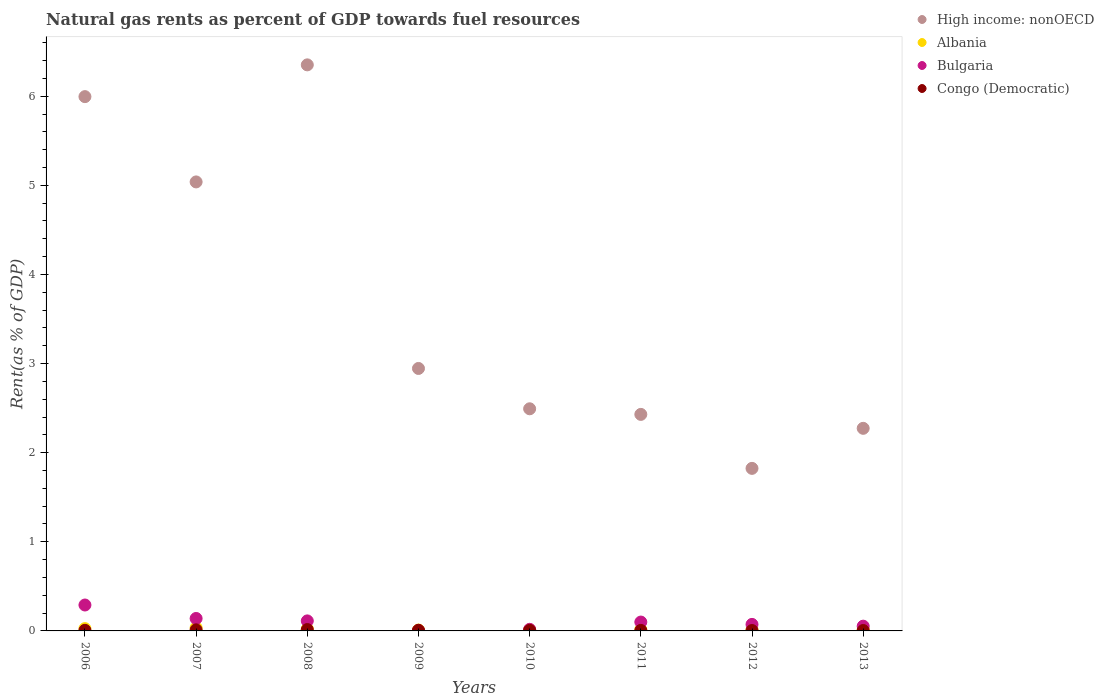Is the number of dotlines equal to the number of legend labels?
Provide a succinct answer. Yes. What is the matural gas rent in Congo (Democratic) in 2011?
Your answer should be compact. 0.01. Across all years, what is the maximum matural gas rent in Bulgaria?
Your answer should be compact. 0.29. Across all years, what is the minimum matural gas rent in Albania?
Make the answer very short. 0.01. What is the total matural gas rent in High income: nonOECD in the graph?
Give a very brief answer. 29.35. What is the difference between the matural gas rent in Congo (Democratic) in 2006 and that in 2012?
Provide a succinct answer. 0. What is the difference between the matural gas rent in Congo (Democratic) in 2011 and the matural gas rent in Albania in 2012?
Your answer should be very brief. -0.01. What is the average matural gas rent in Congo (Democratic) per year?
Give a very brief answer. 0.01. In the year 2008, what is the difference between the matural gas rent in Congo (Democratic) and matural gas rent in Albania?
Provide a short and direct response. -0.01. What is the ratio of the matural gas rent in Congo (Democratic) in 2007 to that in 2013?
Your response must be concise. 2.74. What is the difference between the highest and the second highest matural gas rent in Albania?
Your answer should be very brief. 0.01. What is the difference between the highest and the lowest matural gas rent in High income: nonOECD?
Your answer should be compact. 4.53. In how many years, is the matural gas rent in High income: nonOECD greater than the average matural gas rent in High income: nonOECD taken over all years?
Provide a short and direct response. 3. Does the matural gas rent in Albania monotonically increase over the years?
Provide a short and direct response. No. Is the matural gas rent in Bulgaria strictly greater than the matural gas rent in Congo (Democratic) over the years?
Your response must be concise. No. Is the matural gas rent in Congo (Democratic) strictly less than the matural gas rent in High income: nonOECD over the years?
Your answer should be very brief. Yes. How many dotlines are there?
Your response must be concise. 4. How many years are there in the graph?
Keep it short and to the point. 8. Does the graph contain any zero values?
Make the answer very short. No. How many legend labels are there?
Your answer should be very brief. 4. How are the legend labels stacked?
Keep it short and to the point. Vertical. What is the title of the graph?
Your response must be concise. Natural gas rents as percent of GDP towards fuel resources. Does "Syrian Arab Republic" appear as one of the legend labels in the graph?
Your answer should be very brief. No. What is the label or title of the X-axis?
Provide a succinct answer. Years. What is the label or title of the Y-axis?
Your answer should be very brief. Rent(as % of GDP). What is the Rent(as % of GDP) of High income: nonOECD in 2006?
Ensure brevity in your answer.  6. What is the Rent(as % of GDP) of Albania in 2006?
Make the answer very short. 0.03. What is the Rent(as % of GDP) of Bulgaria in 2006?
Your answer should be compact. 0.29. What is the Rent(as % of GDP) in Congo (Democratic) in 2006?
Your answer should be compact. 0.01. What is the Rent(as % of GDP) in High income: nonOECD in 2007?
Provide a short and direct response. 5.04. What is the Rent(as % of GDP) of Albania in 2007?
Keep it short and to the point. 0.03. What is the Rent(as % of GDP) in Bulgaria in 2007?
Make the answer very short. 0.14. What is the Rent(as % of GDP) in Congo (Democratic) in 2007?
Offer a very short reply. 0.01. What is the Rent(as % of GDP) in High income: nonOECD in 2008?
Provide a short and direct response. 6.35. What is the Rent(as % of GDP) of Albania in 2008?
Provide a succinct answer. 0.02. What is the Rent(as % of GDP) in Bulgaria in 2008?
Make the answer very short. 0.11. What is the Rent(as % of GDP) in Congo (Democratic) in 2008?
Make the answer very short. 0.02. What is the Rent(as % of GDP) of High income: nonOECD in 2009?
Ensure brevity in your answer.  2.95. What is the Rent(as % of GDP) in Albania in 2009?
Offer a terse response. 0.01. What is the Rent(as % of GDP) in Bulgaria in 2009?
Your answer should be compact. 0. What is the Rent(as % of GDP) of Congo (Democratic) in 2009?
Provide a succinct answer. 0.01. What is the Rent(as % of GDP) in High income: nonOECD in 2010?
Provide a succinct answer. 2.49. What is the Rent(as % of GDP) of Albania in 2010?
Make the answer very short. 0.01. What is the Rent(as % of GDP) in Bulgaria in 2010?
Your answer should be compact. 0.02. What is the Rent(as % of GDP) in Congo (Democratic) in 2010?
Offer a terse response. 0.01. What is the Rent(as % of GDP) of High income: nonOECD in 2011?
Your answer should be compact. 2.43. What is the Rent(as % of GDP) of Albania in 2011?
Provide a short and direct response. 0.01. What is the Rent(as % of GDP) of Bulgaria in 2011?
Your answer should be very brief. 0.1. What is the Rent(as % of GDP) of Congo (Democratic) in 2011?
Offer a very short reply. 0.01. What is the Rent(as % of GDP) of High income: nonOECD in 2012?
Offer a very short reply. 1.82. What is the Rent(as % of GDP) of Albania in 2012?
Offer a terse response. 0.01. What is the Rent(as % of GDP) of Bulgaria in 2012?
Keep it short and to the point. 0.07. What is the Rent(as % of GDP) in Congo (Democratic) in 2012?
Give a very brief answer. 0. What is the Rent(as % of GDP) in High income: nonOECD in 2013?
Your response must be concise. 2.27. What is the Rent(as % of GDP) in Albania in 2013?
Make the answer very short. 0.02. What is the Rent(as % of GDP) of Bulgaria in 2013?
Ensure brevity in your answer.  0.05. What is the Rent(as % of GDP) of Congo (Democratic) in 2013?
Your response must be concise. 0. Across all years, what is the maximum Rent(as % of GDP) of High income: nonOECD?
Ensure brevity in your answer.  6.35. Across all years, what is the maximum Rent(as % of GDP) of Albania?
Offer a terse response. 0.03. Across all years, what is the maximum Rent(as % of GDP) in Bulgaria?
Ensure brevity in your answer.  0.29. Across all years, what is the maximum Rent(as % of GDP) of Congo (Democratic)?
Provide a succinct answer. 0.02. Across all years, what is the minimum Rent(as % of GDP) in High income: nonOECD?
Ensure brevity in your answer.  1.82. Across all years, what is the minimum Rent(as % of GDP) of Albania?
Give a very brief answer. 0.01. Across all years, what is the minimum Rent(as % of GDP) in Bulgaria?
Offer a terse response. 0. Across all years, what is the minimum Rent(as % of GDP) in Congo (Democratic)?
Your answer should be very brief. 0. What is the total Rent(as % of GDP) of High income: nonOECD in the graph?
Your answer should be very brief. 29.35. What is the total Rent(as % of GDP) of Albania in the graph?
Your answer should be very brief. 0.15. What is the total Rent(as % of GDP) of Bulgaria in the graph?
Your response must be concise. 0.79. What is the total Rent(as % of GDP) in Congo (Democratic) in the graph?
Your answer should be compact. 0.06. What is the difference between the Rent(as % of GDP) of Albania in 2006 and that in 2007?
Keep it short and to the point. -0.01. What is the difference between the Rent(as % of GDP) in Bulgaria in 2006 and that in 2007?
Give a very brief answer. 0.15. What is the difference between the Rent(as % of GDP) in Congo (Democratic) in 2006 and that in 2007?
Your answer should be very brief. -0.01. What is the difference between the Rent(as % of GDP) in High income: nonOECD in 2006 and that in 2008?
Offer a very short reply. -0.36. What is the difference between the Rent(as % of GDP) of Albania in 2006 and that in 2008?
Your response must be concise. 0. What is the difference between the Rent(as % of GDP) in Bulgaria in 2006 and that in 2008?
Make the answer very short. 0.18. What is the difference between the Rent(as % of GDP) in Congo (Democratic) in 2006 and that in 2008?
Offer a very short reply. -0.01. What is the difference between the Rent(as % of GDP) of High income: nonOECD in 2006 and that in 2009?
Offer a very short reply. 3.05. What is the difference between the Rent(as % of GDP) of Albania in 2006 and that in 2009?
Your response must be concise. 0.02. What is the difference between the Rent(as % of GDP) of Bulgaria in 2006 and that in 2009?
Provide a succinct answer. 0.29. What is the difference between the Rent(as % of GDP) in Congo (Democratic) in 2006 and that in 2009?
Your answer should be very brief. -0. What is the difference between the Rent(as % of GDP) in High income: nonOECD in 2006 and that in 2010?
Ensure brevity in your answer.  3.5. What is the difference between the Rent(as % of GDP) of Albania in 2006 and that in 2010?
Your response must be concise. 0.01. What is the difference between the Rent(as % of GDP) in Bulgaria in 2006 and that in 2010?
Ensure brevity in your answer.  0.27. What is the difference between the Rent(as % of GDP) in Congo (Democratic) in 2006 and that in 2010?
Your response must be concise. 0. What is the difference between the Rent(as % of GDP) of High income: nonOECD in 2006 and that in 2011?
Provide a short and direct response. 3.57. What is the difference between the Rent(as % of GDP) in Albania in 2006 and that in 2011?
Ensure brevity in your answer.  0.01. What is the difference between the Rent(as % of GDP) in Bulgaria in 2006 and that in 2011?
Give a very brief answer. 0.19. What is the difference between the Rent(as % of GDP) in Congo (Democratic) in 2006 and that in 2011?
Give a very brief answer. 0. What is the difference between the Rent(as % of GDP) in High income: nonOECD in 2006 and that in 2012?
Give a very brief answer. 4.17. What is the difference between the Rent(as % of GDP) of Albania in 2006 and that in 2012?
Give a very brief answer. 0.01. What is the difference between the Rent(as % of GDP) of Bulgaria in 2006 and that in 2012?
Make the answer very short. 0.22. What is the difference between the Rent(as % of GDP) in Congo (Democratic) in 2006 and that in 2012?
Ensure brevity in your answer.  0. What is the difference between the Rent(as % of GDP) in High income: nonOECD in 2006 and that in 2013?
Offer a very short reply. 3.72. What is the difference between the Rent(as % of GDP) in Albania in 2006 and that in 2013?
Make the answer very short. 0.01. What is the difference between the Rent(as % of GDP) of Bulgaria in 2006 and that in 2013?
Your response must be concise. 0.24. What is the difference between the Rent(as % of GDP) of Congo (Democratic) in 2006 and that in 2013?
Give a very brief answer. 0. What is the difference between the Rent(as % of GDP) in High income: nonOECD in 2007 and that in 2008?
Provide a short and direct response. -1.31. What is the difference between the Rent(as % of GDP) in Albania in 2007 and that in 2008?
Provide a short and direct response. 0.01. What is the difference between the Rent(as % of GDP) of Bulgaria in 2007 and that in 2008?
Your response must be concise. 0.03. What is the difference between the Rent(as % of GDP) of Congo (Democratic) in 2007 and that in 2008?
Provide a succinct answer. -0. What is the difference between the Rent(as % of GDP) of High income: nonOECD in 2007 and that in 2009?
Offer a terse response. 2.09. What is the difference between the Rent(as % of GDP) in Albania in 2007 and that in 2009?
Your answer should be compact. 0.03. What is the difference between the Rent(as % of GDP) in Bulgaria in 2007 and that in 2009?
Your response must be concise. 0.14. What is the difference between the Rent(as % of GDP) in Congo (Democratic) in 2007 and that in 2009?
Keep it short and to the point. 0. What is the difference between the Rent(as % of GDP) in High income: nonOECD in 2007 and that in 2010?
Your response must be concise. 2.55. What is the difference between the Rent(as % of GDP) of Albania in 2007 and that in 2010?
Your response must be concise. 0.02. What is the difference between the Rent(as % of GDP) of Bulgaria in 2007 and that in 2010?
Make the answer very short. 0.12. What is the difference between the Rent(as % of GDP) of Congo (Democratic) in 2007 and that in 2010?
Keep it short and to the point. 0.01. What is the difference between the Rent(as % of GDP) of High income: nonOECD in 2007 and that in 2011?
Your answer should be compact. 2.61. What is the difference between the Rent(as % of GDP) in Albania in 2007 and that in 2011?
Offer a terse response. 0.02. What is the difference between the Rent(as % of GDP) of Bulgaria in 2007 and that in 2011?
Ensure brevity in your answer.  0.04. What is the difference between the Rent(as % of GDP) of Congo (Democratic) in 2007 and that in 2011?
Provide a succinct answer. 0.01. What is the difference between the Rent(as % of GDP) of High income: nonOECD in 2007 and that in 2012?
Provide a succinct answer. 3.21. What is the difference between the Rent(as % of GDP) of Albania in 2007 and that in 2012?
Keep it short and to the point. 0.02. What is the difference between the Rent(as % of GDP) in Bulgaria in 2007 and that in 2012?
Your answer should be compact. 0.07. What is the difference between the Rent(as % of GDP) in Congo (Democratic) in 2007 and that in 2012?
Your answer should be compact. 0.01. What is the difference between the Rent(as % of GDP) of High income: nonOECD in 2007 and that in 2013?
Your answer should be compact. 2.77. What is the difference between the Rent(as % of GDP) of Albania in 2007 and that in 2013?
Keep it short and to the point. 0.02. What is the difference between the Rent(as % of GDP) in Bulgaria in 2007 and that in 2013?
Offer a very short reply. 0.09. What is the difference between the Rent(as % of GDP) in Congo (Democratic) in 2007 and that in 2013?
Offer a terse response. 0.01. What is the difference between the Rent(as % of GDP) of High income: nonOECD in 2008 and that in 2009?
Offer a very short reply. 3.41. What is the difference between the Rent(as % of GDP) of Albania in 2008 and that in 2009?
Offer a very short reply. 0.01. What is the difference between the Rent(as % of GDP) of Bulgaria in 2008 and that in 2009?
Offer a terse response. 0.11. What is the difference between the Rent(as % of GDP) of Congo (Democratic) in 2008 and that in 2009?
Provide a succinct answer. 0.01. What is the difference between the Rent(as % of GDP) in High income: nonOECD in 2008 and that in 2010?
Your answer should be compact. 3.86. What is the difference between the Rent(as % of GDP) in Albania in 2008 and that in 2010?
Your answer should be compact. 0.01. What is the difference between the Rent(as % of GDP) in Bulgaria in 2008 and that in 2010?
Your answer should be compact. 0.09. What is the difference between the Rent(as % of GDP) in Congo (Democratic) in 2008 and that in 2010?
Ensure brevity in your answer.  0.01. What is the difference between the Rent(as % of GDP) in High income: nonOECD in 2008 and that in 2011?
Make the answer very short. 3.92. What is the difference between the Rent(as % of GDP) in Albania in 2008 and that in 2011?
Keep it short and to the point. 0.01. What is the difference between the Rent(as % of GDP) of Bulgaria in 2008 and that in 2011?
Provide a short and direct response. 0.01. What is the difference between the Rent(as % of GDP) of Congo (Democratic) in 2008 and that in 2011?
Your answer should be very brief. 0.01. What is the difference between the Rent(as % of GDP) of High income: nonOECD in 2008 and that in 2012?
Give a very brief answer. 4.53. What is the difference between the Rent(as % of GDP) of Albania in 2008 and that in 2012?
Give a very brief answer. 0.01. What is the difference between the Rent(as % of GDP) in Bulgaria in 2008 and that in 2012?
Offer a very short reply. 0.04. What is the difference between the Rent(as % of GDP) in Congo (Democratic) in 2008 and that in 2012?
Offer a very short reply. 0.01. What is the difference between the Rent(as % of GDP) of High income: nonOECD in 2008 and that in 2013?
Keep it short and to the point. 4.08. What is the difference between the Rent(as % of GDP) in Albania in 2008 and that in 2013?
Your answer should be compact. 0.01. What is the difference between the Rent(as % of GDP) in Bulgaria in 2008 and that in 2013?
Ensure brevity in your answer.  0.06. What is the difference between the Rent(as % of GDP) in Congo (Democratic) in 2008 and that in 2013?
Offer a terse response. 0.01. What is the difference between the Rent(as % of GDP) in High income: nonOECD in 2009 and that in 2010?
Provide a succinct answer. 0.45. What is the difference between the Rent(as % of GDP) of Albania in 2009 and that in 2010?
Keep it short and to the point. -0. What is the difference between the Rent(as % of GDP) in Bulgaria in 2009 and that in 2010?
Offer a terse response. -0.01. What is the difference between the Rent(as % of GDP) of Congo (Democratic) in 2009 and that in 2010?
Your answer should be very brief. 0. What is the difference between the Rent(as % of GDP) of High income: nonOECD in 2009 and that in 2011?
Your answer should be very brief. 0.52. What is the difference between the Rent(as % of GDP) in Albania in 2009 and that in 2011?
Keep it short and to the point. -0. What is the difference between the Rent(as % of GDP) in Bulgaria in 2009 and that in 2011?
Offer a very short reply. -0.1. What is the difference between the Rent(as % of GDP) of Congo (Democratic) in 2009 and that in 2011?
Keep it short and to the point. 0. What is the difference between the Rent(as % of GDP) in High income: nonOECD in 2009 and that in 2012?
Provide a succinct answer. 1.12. What is the difference between the Rent(as % of GDP) in Albania in 2009 and that in 2012?
Your answer should be compact. -0. What is the difference between the Rent(as % of GDP) in Bulgaria in 2009 and that in 2012?
Your answer should be compact. -0.07. What is the difference between the Rent(as % of GDP) of Congo (Democratic) in 2009 and that in 2012?
Offer a very short reply. 0. What is the difference between the Rent(as % of GDP) of High income: nonOECD in 2009 and that in 2013?
Keep it short and to the point. 0.67. What is the difference between the Rent(as % of GDP) of Albania in 2009 and that in 2013?
Offer a terse response. -0.01. What is the difference between the Rent(as % of GDP) of Bulgaria in 2009 and that in 2013?
Provide a succinct answer. -0.05. What is the difference between the Rent(as % of GDP) of Congo (Democratic) in 2009 and that in 2013?
Provide a short and direct response. 0. What is the difference between the Rent(as % of GDP) in High income: nonOECD in 2010 and that in 2011?
Keep it short and to the point. 0.06. What is the difference between the Rent(as % of GDP) of Albania in 2010 and that in 2011?
Your answer should be compact. -0. What is the difference between the Rent(as % of GDP) in Bulgaria in 2010 and that in 2011?
Make the answer very short. -0.08. What is the difference between the Rent(as % of GDP) in High income: nonOECD in 2010 and that in 2012?
Keep it short and to the point. 0.67. What is the difference between the Rent(as % of GDP) in Albania in 2010 and that in 2012?
Provide a succinct answer. 0. What is the difference between the Rent(as % of GDP) of Bulgaria in 2010 and that in 2012?
Offer a very short reply. -0.06. What is the difference between the Rent(as % of GDP) in Congo (Democratic) in 2010 and that in 2012?
Your answer should be very brief. 0. What is the difference between the Rent(as % of GDP) of High income: nonOECD in 2010 and that in 2013?
Offer a terse response. 0.22. What is the difference between the Rent(as % of GDP) of Albania in 2010 and that in 2013?
Give a very brief answer. -0. What is the difference between the Rent(as % of GDP) in Bulgaria in 2010 and that in 2013?
Your answer should be compact. -0.04. What is the difference between the Rent(as % of GDP) in Congo (Democratic) in 2010 and that in 2013?
Provide a short and direct response. 0. What is the difference between the Rent(as % of GDP) in High income: nonOECD in 2011 and that in 2012?
Your answer should be compact. 0.61. What is the difference between the Rent(as % of GDP) in Albania in 2011 and that in 2012?
Make the answer very short. 0. What is the difference between the Rent(as % of GDP) in Bulgaria in 2011 and that in 2012?
Make the answer very short. 0.03. What is the difference between the Rent(as % of GDP) of Congo (Democratic) in 2011 and that in 2012?
Offer a very short reply. 0. What is the difference between the Rent(as % of GDP) in High income: nonOECD in 2011 and that in 2013?
Make the answer very short. 0.16. What is the difference between the Rent(as % of GDP) of Albania in 2011 and that in 2013?
Make the answer very short. -0. What is the difference between the Rent(as % of GDP) in Bulgaria in 2011 and that in 2013?
Your answer should be compact. 0.05. What is the difference between the Rent(as % of GDP) in Congo (Democratic) in 2011 and that in 2013?
Provide a short and direct response. 0. What is the difference between the Rent(as % of GDP) of High income: nonOECD in 2012 and that in 2013?
Your answer should be compact. -0.45. What is the difference between the Rent(as % of GDP) in Albania in 2012 and that in 2013?
Offer a terse response. -0. What is the difference between the Rent(as % of GDP) of Bulgaria in 2012 and that in 2013?
Provide a short and direct response. 0.02. What is the difference between the Rent(as % of GDP) of Congo (Democratic) in 2012 and that in 2013?
Keep it short and to the point. -0. What is the difference between the Rent(as % of GDP) of High income: nonOECD in 2006 and the Rent(as % of GDP) of Albania in 2007?
Keep it short and to the point. 5.96. What is the difference between the Rent(as % of GDP) of High income: nonOECD in 2006 and the Rent(as % of GDP) of Bulgaria in 2007?
Your answer should be very brief. 5.86. What is the difference between the Rent(as % of GDP) in High income: nonOECD in 2006 and the Rent(as % of GDP) in Congo (Democratic) in 2007?
Offer a very short reply. 5.98. What is the difference between the Rent(as % of GDP) of Albania in 2006 and the Rent(as % of GDP) of Bulgaria in 2007?
Your answer should be compact. -0.11. What is the difference between the Rent(as % of GDP) in Albania in 2006 and the Rent(as % of GDP) in Congo (Democratic) in 2007?
Offer a terse response. 0.01. What is the difference between the Rent(as % of GDP) in Bulgaria in 2006 and the Rent(as % of GDP) in Congo (Democratic) in 2007?
Provide a short and direct response. 0.28. What is the difference between the Rent(as % of GDP) of High income: nonOECD in 2006 and the Rent(as % of GDP) of Albania in 2008?
Ensure brevity in your answer.  5.97. What is the difference between the Rent(as % of GDP) in High income: nonOECD in 2006 and the Rent(as % of GDP) in Bulgaria in 2008?
Your answer should be compact. 5.88. What is the difference between the Rent(as % of GDP) in High income: nonOECD in 2006 and the Rent(as % of GDP) in Congo (Democratic) in 2008?
Your answer should be compact. 5.98. What is the difference between the Rent(as % of GDP) of Albania in 2006 and the Rent(as % of GDP) of Bulgaria in 2008?
Provide a succinct answer. -0.09. What is the difference between the Rent(as % of GDP) in Albania in 2006 and the Rent(as % of GDP) in Congo (Democratic) in 2008?
Your answer should be compact. 0.01. What is the difference between the Rent(as % of GDP) of Bulgaria in 2006 and the Rent(as % of GDP) of Congo (Democratic) in 2008?
Give a very brief answer. 0.28. What is the difference between the Rent(as % of GDP) of High income: nonOECD in 2006 and the Rent(as % of GDP) of Albania in 2009?
Your answer should be compact. 5.99. What is the difference between the Rent(as % of GDP) in High income: nonOECD in 2006 and the Rent(as % of GDP) in Bulgaria in 2009?
Provide a short and direct response. 5.99. What is the difference between the Rent(as % of GDP) in High income: nonOECD in 2006 and the Rent(as % of GDP) in Congo (Democratic) in 2009?
Your response must be concise. 5.99. What is the difference between the Rent(as % of GDP) of Albania in 2006 and the Rent(as % of GDP) of Bulgaria in 2009?
Your response must be concise. 0.02. What is the difference between the Rent(as % of GDP) in Albania in 2006 and the Rent(as % of GDP) in Congo (Democratic) in 2009?
Your response must be concise. 0.02. What is the difference between the Rent(as % of GDP) of Bulgaria in 2006 and the Rent(as % of GDP) of Congo (Democratic) in 2009?
Provide a short and direct response. 0.28. What is the difference between the Rent(as % of GDP) of High income: nonOECD in 2006 and the Rent(as % of GDP) of Albania in 2010?
Ensure brevity in your answer.  5.98. What is the difference between the Rent(as % of GDP) of High income: nonOECD in 2006 and the Rent(as % of GDP) of Bulgaria in 2010?
Provide a short and direct response. 5.98. What is the difference between the Rent(as % of GDP) in High income: nonOECD in 2006 and the Rent(as % of GDP) in Congo (Democratic) in 2010?
Your response must be concise. 5.99. What is the difference between the Rent(as % of GDP) of Albania in 2006 and the Rent(as % of GDP) of Bulgaria in 2010?
Give a very brief answer. 0.01. What is the difference between the Rent(as % of GDP) of Albania in 2006 and the Rent(as % of GDP) of Congo (Democratic) in 2010?
Your response must be concise. 0.02. What is the difference between the Rent(as % of GDP) in Bulgaria in 2006 and the Rent(as % of GDP) in Congo (Democratic) in 2010?
Your answer should be compact. 0.28. What is the difference between the Rent(as % of GDP) in High income: nonOECD in 2006 and the Rent(as % of GDP) in Albania in 2011?
Provide a succinct answer. 5.98. What is the difference between the Rent(as % of GDP) of High income: nonOECD in 2006 and the Rent(as % of GDP) of Bulgaria in 2011?
Your answer should be compact. 5.9. What is the difference between the Rent(as % of GDP) of High income: nonOECD in 2006 and the Rent(as % of GDP) of Congo (Democratic) in 2011?
Your answer should be very brief. 5.99. What is the difference between the Rent(as % of GDP) in Albania in 2006 and the Rent(as % of GDP) in Bulgaria in 2011?
Ensure brevity in your answer.  -0.07. What is the difference between the Rent(as % of GDP) in Albania in 2006 and the Rent(as % of GDP) in Congo (Democratic) in 2011?
Ensure brevity in your answer.  0.02. What is the difference between the Rent(as % of GDP) of Bulgaria in 2006 and the Rent(as % of GDP) of Congo (Democratic) in 2011?
Give a very brief answer. 0.28. What is the difference between the Rent(as % of GDP) of High income: nonOECD in 2006 and the Rent(as % of GDP) of Albania in 2012?
Your response must be concise. 5.98. What is the difference between the Rent(as % of GDP) of High income: nonOECD in 2006 and the Rent(as % of GDP) of Bulgaria in 2012?
Make the answer very short. 5.92. What is the difference between the Rent(as % of GDP) in High income: nonOECD in 2006 and the Rent(as % of GDP) in Congo (Democratic) in 2012?
Your answer should be compact. 5.99. What is the difference between the Rent(as % of GDP) in Albania in 2006 and the Rent(as % of GDP) in Bulgaria in 2012?
Keep it short and to the point. -0.05. What is the difference between the Rent(as % of GDP) in Albania in 2006 and the Rent(as % of GDP) in Congo (Democratic) in 2012?
Provide a succinct answer. 0.02. What is the difference between the Rent(as % of GDP) of Bulgaria in 2006 and the Rent(as % of GDP) of Congo (Democratic) in 2012?
Keep it short and to the point. 0.29. What is the difference between the Rent(as % of GDP) in High income: nonOECD in 2006 and the Rent(as % of GDP) in Albania in 2013?
Your response must be concise. 5.98. What is the difference between the Rent(as % of GDP) in High income: nonOECD in 2006 and the Rent(as % of GDP) in Bulgaria in 2013?
Offer a very short reply. 5.94. What is the difference between the Rent(as % of GDP) of High income: nonOECD in 2006 and the Rent(as % of GDP) of Congo (Democratic) in 2013?
Your response must be concise. 5.99. What is the difference between the Rent(as % of GDP) in Albania in 2006 and the Rent(as % of GDP) in Bulgaria in 2013?
Keep it short and to the point. -0.03. What is the difference between the Rent(as % of GDP) in Albania in 2006 and the Rent(as % of GDP) in Congo (Democratic) in 2013?
Your response must be concise. 0.02. What is the difference between the Rent(as % of GDP) of Bulgaria in 2006 and the Rent(as % of GDP) of Congo (Democratic) in 2013?
Keep it short and to the point. 0.29. What is the difference between the Rent(as % of GDP) of High income: nonOECD in 2007 and the Rent(as % of GDP) of Albania in 2008?
Your response must be concise. 5.02. What is the difference between the Rent(as % of GDP) of High income: nonOECD in 2007 and the Rent(as % of GDP) of Bulgaria in 2008?
Offer a very short reply. 4.93. What is the difference between the Rent(as % of GDP) of High income: nonOECD in 2007 and the Rent(as % of GDP) of Congo (Democratic) in 2008?
Your answer should be compact. 5.02. What is the difference between the Rent(as % of GDP) of Albania in 2007 and the Rent(as % of GDP) of Bulgaria in 2008?
Offer a terse response. -0.08. What is the difference between the Rent(as % of GDP) of Albania in 2007 and the Rent(as % of GDP) of Congo (Democratic) in 2008?
Your answer should be compact. 0.02. What is the difference between the Rent(as % of GDP) in Bulgaria in 2007 and the Rent(as % of GDP) in Congo (Democratic) in 2008?
Provide a short and direct response. 0.12. What is the difference between the Rent(as % of GDP) of High income: nonOECD in 2007 and the Rent(as % of GDP) of Albania in 2009?
Provide a short and direct response. 5.03. What is the difference between the Rent(as % of GDP) in High income: nonOECD in 2007 and the Rent(as % of GDP) in Bulgaria in 2009?
Make the answer very short. 5.03. What is the difference between the Rent(as % of GDP) in High income: nonOECD in 2007 and the Rent(as % of GDP) in Congo (Democratic) in 2009?
Provide a succinct answer. 5.03. What is the difference between the Rent(as % of GDP) of Albania in 2007 and the Rent(as % of GDP) of Bulgaria in 2009?
Keep it short and to the point. 0.03. What is the difference between the Rent(as % of GDP) in Albania in 2007 and the Rent(as % of GDP) in Congo (Democratic) in 2009?
Ensure brevity in your answer.  0.03. What is the difference between the Rent(as % of GDP) of Bulgaria in 2007 and the Rent(as % of GDP) of Congo (Democratic) in 2009?
Ensure brevity in your answer.  0.13. What is the difference between the Rent(as % of GDP) of High income: nonOECD in 2007 and the Rent(as % of GDP) of Albania in 2010?
Offer a very short reply. 5.02. What is the difference between the Rent(as % of GDP) in High income: nonOECD in 2007 and the Rent(as % of GDP) in Bulgaria in 2010?
Your answer should be compact. 5.02. What is the difference between the Rent(as % of GDP) in High income: nonOECD in 2007 and the Rent(as % of GDP) in Congo (Democratic) in 2010?
Ensure brevity in your answer.  5.03. What is the difference between the Rent(as % of GDP) in Albania in 2007 and the Rent(as % of GDP) in Bulgaria in 2010?
Ensure brevity in your answer.  0.02. What is the difference between the Rent(as % of GDP) of Albania in 2007 and the Rent(as % of GDP) of Congo (Democratic) in 2010?
Give a very brief answer. 0.03. What is the difference between the Rent(as % of GDP) of Bulgaria in 2007 and the Rent(as % of GDP) of Congo (Democratic) in 2010?
Ensure brevity in your answer.  0.13. What is the difference between the Rent(as % of GDP) in High income: nonOECD in 2007 and the Rent(as % of GDP) in Albania in 2011?
Ensure brevity in your answer.  5.02. What is the difference between the Rent(as % of GDP) in High income: nonOECD in 2007 and the Rent(as % of GDP) in Bulgaria in 2011?
Give a very brief answer. 4.94. What is the difference between the Rent(as % of GDP) in High income: nonOECD in 2007 and the Rent(as % of GDP) in Congo (Democratic) in 2011?
Give a very brief answer. 5.03. What is the difference between the Rent(as % of GDP) in Albania in 2007 and the Rent(as % of GDP) in Bulgaria in 2011?
Provide a succinct answer. -0.06. What is the difference between the Rent(as % of GDP) of Albania in 2007 and the Rent(as % of GDP) of Congo (Democratic) in 2011?
Offer a very short reply. 0.03. What is the difference between the Rent(as % of GDP) in Bulgaria in 2007 and the Rent(as % of GDP) in Congo (Democratic) in 2011?
Give a very brief answer. 0.13. What is the difference between the Rent(as % of GDP) of High income: nonOECD in 2007 and the Rent(as % of GDP) of Albania in 2012?
Give a very brief answer. 5.03. What is the difference between the Rent(as % of GDP) in High income: nonOECD in 2007 and the Rent(as % of GDP) in Bulgaria in 2012?
Your answer should be very brief. 4.97. What is the difference between the Rent(as % of GDP) in High income: nonOECD in 2007 and the Rent(as % of GDP) in Congo (Democratic) in 2012?
Make the answer very short. 5.03. What is the difference between the Rent(as % of GDP) in Albania in 2007 and the Rent(as % of GDP) in Bulgaria in 2012?
Offer a very short reply. -0.04. What is the difference between the Rent(as % of GDP) in Albania in 2007 and the Rent(as % of GDP) in Congo (Democratic) in 2012?
Offer a very short reply. 0.03. What is the difference between the Rent(as % of GDP) of Bulgaria in 2007 and the Rent(as % of GDP) of Congo (Democratic) in 2012?
Provide a short and direct response. 0.14. What is the difference between the Rent(as % of GDP) in High income: nonOECD in 2007 and the Rent(as % of GDP) in Albania in 2013?
Your response must be concise. 5.02. What is the difference between the Rent(as % of GDP) of High income: nonOECD in 2007 and the Rent(as % of GDP) of Bulgaria in 2013?
Provide a succinct answer. 4.99. What is the difference between the Rent(as % of GDP) of High income: nonOECD in 2007 and the Rent(as % of GDP) of Congo (Democratic) in 2013?
Your answer should be compact. 5.03. What is the difference between the Rent(as % of GDP) of Albania in 2007 and the Rent(as % of GDP) of Bulgaria in 2013?
Give a very brief answer. -0.02. What is the difference between the Rent(as % of GDP) in Albania in 2007 and the Rent(as % of GDP) in Congo (Democratic) in 2013?
Provide a short and direct response. 0.03. What is the difference between the Rent(as % of GDP) of Bulgaria in 2007 and the Rent(as % of GDP) of Congo (Democratic) in 2013?
Give a very brief answer. 0.14. What is the difference between the Rent(as % of GDP) in High income: nonOECD in 2008 and the Rent(as % of GDP) in Albania in 2009?
Provide a short and direct response. 6.34. What is the difference between the Rent(as % of GDP) in High income: nonOECD in 2008 and the Rent(as % of GDP) in Bulgaria in 2009?
Offer a very short reply. 6.35. What is the difference between the Rent(as % of GDP) of High income: nonOECD in 2008 and the Rent(as % of GDP) of Congo (Democratic) in 2009?
Your answer should be compact. 6.34. What is the difference between the Rent(as % of GDP) of Albania in 2008 and the Rent(as % of GDP) of Bulgaria in 2009?
Your response must be concise. 0.02. What is the difference between the Rent(as % of GDP) in Albania in 2008 and the Rent(as % of GDP) in Congo (Democratic) in 2009?
Your answer should be compact. 0.01. What is the difference between the Rent(as % of GDP) in Bulgaria in 2008 and the Rent(as % of GDP) in Congo (Democratic) in 2009?
Your answer should be compact. 0.11. What is the difference between the Rent(as % of GDP) of High income: nonOECD in 2008 and the Rent(as % of GDP) of Albania in 2010?
Offer a terse response. 6.34. What is the difference between the Rent(as % of GDP) in High income: nonOECD in 2008 and the Rent(as % of GDP) in Bulgaria in 2010?
Give a very brief answer. 6.33. What is the difference between the Rent(as % of GDP) in High income: nonOECD in 2008 and the Rent(as % of GDP) in Congo (Democratic) in 2010?
Keep it short and to the point. 6.35. What is the difference between the Rent(as % of GDP) of Albania in 2008 and the Rent(as % of GDP) of Bulgaria in 2010?
Give a very brief answer. 0. What is the difference between the Rent(as % of GDP) of Albania in 2008 and the Rent(as % of GDP) of Congo (Democratic) in 2010?
Offer a terse response. 0.02. What is the difference between the Rent(as % of GDP) of Bulgaria in 2008 and the Rent(as % of GDP) of Congo (Democratic) in 2010?
Keep it short and to the point. 0.11. What is the difference between the Rent(as % of GDP) of High income: nonOECD in 2008 and the Rent(as % of GDP) of Albania in 2011?
Your answer should be compact. 6.34. What is the difference between the Rent(as % of GDP) in High income: nonOECD in 2008 and the Rent(as % of GDP) in Bulgaria in 2011?
Offer a terse response. 6.25. What is the difference between the Rent(as % of GDP) of High income: nonOECD in 2008 and the Rent(as % of GDP) of Congo (Democratic) in 2011?
Give a very brief answer. 6.35. What is the difference between the Rent(as % of GDP) of Albania in 2008 and the Rent(as % of GDP) of Bulgaria in 2011?
Ensure brevity in your answer.  -0.08. What is the difference between the Rent(as % of GDP) in Albania in 2008 and the Rent(as % of GDP) in Congo (Democratic) in 2011?
Give a very brief answer. 0.02. What is the difference between the Rent(as % of GDP) of Bulgaria in 2008 and the Rent(as % of GDP) of Congo (Democratic) in 2011?
Give a very brief answer. 0.11. What is the difference between the Rent(as % of GDP) of High income: nonOECD in 2008 and the Rent(as % of GDP) of Albania in 2012?
Offer a terse response. 6.34. What is the difference between the Rent(as % of GDP) of High income: nonOECD in 2008 and the Rent(as % of GDP) of Bulgaria in 2012?
Your answer should be compact. 6.28. What is the difference between the Rent(as % of GDP) of High income: nonOECD in 2008 and the Rent(as % of GDP) of Congo (Democratic) in 2012?
Offer a terse response. 6.35. What is the difference between the Rent(as % of GDP) of Albania in 2008 and the Rent(as % of GDP) of Bulgaria in 2012?
Ensure brevity in your answer.  -0.05. What is the difference between the Rent(as % of GDP) of Albania in 2008 and the Rent(as % of GDP) of Congo (Democratic) in 2012?
Offer a terse response. 0.02. What is the difference between the Rent(as % of GDP) of Bulgaria in 2008 and the Rent(as % of GDP) of Congo (Democratic) in 2012?
Your answer should be compact. 0.11. What is the difference between the Rent(as % of GDP) in High income: nonOECD in 2008 and the Rent(as % of GDP) in Albania in 2013?
Offer a terse response. 6.34. What is the difference between the Rent(as % of GDP) of High income: nonOECD in 2008 and the Rent(as % of GDP) of Bulgaria in 2013?
Give a very brief answer. 6.3. What is the difference between the Rent(as % of GDP) in High income: nonOECD in 2008 and the Rent(as % of GDP) in Congo (Democratic) in 2013?
Your response must be concise. 6.35. What is the difference between the Rent(as % of GDP) in Albania in 2008 and the Rent(as % of GDP) in Bulgaria in 2013?
Offer a terse response. -0.03. What is the difference between the Rent(as % of GDP) in Albania in 2008 and the Rent(as % of GDP) in Congo (Democratic) in 2013?
Ensure brevity in your answer.  0.02. What is the difference between the Rent(as % of GDP) in Bulgaria in 2008 and the Rent(as % of GDP) in Congo (Democratic) in 2013?
Provide a short and direct response. 0.11. What is the difference between the Rent(as % of GDP) of High income: nonOECD in 2009 and the Rent(as % of GDP) of Albania in 2010?
Provide a short and direct response. 2.93. What is the difference between the Rent(as % of GDP) in High income: nonOECD in 2009 and the Rent(as % of GDP) in Bulgaria in 2010?
Give a very brief answer. 2.93. What is the difference between the Rent(as % of GDP) in High income: nonOECD in 2009 and the Rent(as % of GDP) in Congo (Democratic) in 2010?
Provide a short and direct response. 2.94. What is the difference between the Rent(as % of GDP) of Albania in 2009 and the Rent(as % of GDP) of Bulgaria in 2010?
Provide a short and direct response. -0.01. What is the difference between the Rent(as % of GDP) in Albania in 2009 and the Rent(as % of GDP) in Congo (Democratic) in 2010?
Make the answer very short. 0. What is the difference between the Rent(as % of GDP) in Bulgaria in 2009 and the Rent(as % of GDP) in Congo (Democratic) in 2010?
Your response must be concise. -0. What is the difference between the Rent(as % of GDP) of High income: nonOECD in 2009 and the Rent(as % of GDP) of Albania in 2011?
Offer a terse response. 2.93. What is the difference between the Rent(as % of GDP) in High income: nonOECD in 2009 and the Rent(as % of GDP) in Bulgaria in 2011?
Your answer should be compact. 2.85. What is the difference between the Rent(as % of GDP) of High income: nonOECD in 2009 and the Rent(as % of GDP) of Congo (Democratic) in 2011?
Make the answer very short. 2.94. What is the difference between the Rent(as % of GDP) of Albania in 2009 and the Rent(as % of GDP) of Bulgaria in 2011?
Provide a short and direct response. -0.09. What is the difference between the Rent(as % of GDP) in Albania in 2009 and the Rent(as % of GDP) in Congo (Democratic) in 2011?
Provide a short and direct response. 0. What is the difference between the Rent(as % of GDP) of Bulgaria in 2009 and the Rent(as % of GDP) of Congo (Democratic) in 2011?
Your answer should be very brief. -0. What is the difference between the Rent(as % of GDP) in High income: nonOECD in 2009 and the Rent(as % of GDP) in Albania in 2012?
Your answer should be very brief. 2.93. What is the difference between the Rent(as % of GDP) of High income: nonOECD in 2009 and the Rent(as % of GDP) of Bulgaria in 2012?
Offer a very short reply. 2.87. What is the difference between the Rent(as % of GDP) in High income: nonOECD in 2009 and the Rent(as % of GDP) in Congo (Democratic) in 2012?
Your answer should be compact. 2.94. What is the difference between the Rent(as % of GDP) of Albania in 2009 and the Rent(as % of GDP) of Bulgaria in 2012?
Keep it short and to the point. -0.06. What is the difference between the Rent(as % of GDP) in Albania in 2009 and the Rent(as % of GDP) in Congo (Democratic) in 2012?
Provide a succinct answer. 0.01. What is the difference between the Rent(as % of GDP) in Bulgaria in 2009 and the Rent(as % of GDP) in Congo (Democratic) in 2012?
Provide a short and direct response. -0. What is the difference between the Rent(as % of GDP) in High income: nonOECD in 2009 and the Rent(as % of GDP) in Albania in 2013?
Your answer should be very brief. 2.93. What is the difference between the Rent(as % of GDP) in High income: nonOECD in 2009 and the Rent(as % of GDP) in Bulgaria in 2013?
Ensure brevity in your answer.  2.89. What is the difference between the Rent(as % of GDP) of High income: nonOECD in 2009 and the Rent(as % of GDP) of Congo (Democratic) in 2013?
Your response must be concise. 2.94. What is the difference between the Rent(as % of GDP) of Albania in 2009 and the Rent(as % of GDP) of Bulgaria in 2013?
Your response must be concise. -0.04. What is the difference between the Rent(as % of GDP) of Albania in 2009 and the Rent(as % of GDP) of Congo (Democratic) in 2013?
Provide a short and direct response. 0.01. What is the difference between the Rent(as % of GDP) in Bulgaria in 2009 and the Rent(as % of GDP) in Congo (Democratic) in 2013?
Your answer should be very brief. -0. What is the difference between the Rent(as % of GDP) of High income: nonOECD in 2010 and the Rent(as % of GDP) of Albania in 2011?
Keep it short and to the point. 2.48. What is the difference between the Rent(as % of GDP) of High income: nonOECD in 2010 and the Rent(as % of GDP) of Bulgaria in 2011?
Your response must be concise. 2.39. What is the difference between the Rent(as % of GDP) in High income: nonOECD in 2010 and the Rent(as % of GDP) in Congo (Democratic) in 2011?
Keep it short and to the point. 2.49. What is the difference between the Rent(as % of GDP) of Albania in 2010 and the Rent(as % of GDP) of Bulgaria in 2011?
Provide a succinct answer. -0.09. What is the difference between the Rent(as % of GDP) in Albania in 2010 and the Rent(as % of GDP) in Congo (Democratic) in 2011?
Your answer should be compact. 0.01. What is the difference between the Rent(as % of GDP) of Bulgaria in 2010 and the Rent(as % of GDP) of Congo (Democratic) in 2011?
Offer a terse response. 0.01. What is the difference between the Rent(as % of GDP) of High income: nonOECD in 2010 and the Rent(as % of GDP) of Albania in 2012?
Make the answer very short. 2.48. What is the difference between the Rent(as % of GDP) in High income: nonOECD in 2010 and the Rent(as % of GDP) in Bulgaria in 2012?
Make the answer very short. 2.42. What is the difference between the Rent(as % of GDP) in High income: nonOECD in 2010 and the Rent(as % of GDP) in Congo (Democratic) in 2012?
Make the answer very short. 2.49. What is the difference between the Rent(as % of GDP) of Albania in 2010 and the Rent(as % of GDP) of Bulgaria in 2012?
Provide a succinct answer. -0.06. What is the difference between the Rent(as % of GDP) in Albania in 2010 and the Rent(as % of GDP) in Congo (Democratic) in 2012?
Give a very brief answer. 0.01. What is the difference between the Rent(as % of GDP) of Bulgaria in 2010 and the Rent(as % of GDP) of Congo (Democratic) in 2012?
Keep it short and to the point. 0.01. What is the difference between the Rent(as % of GDP) of High income: nonOECD in 2010 and the Rent(as % of GDP) of Albania in 2013?
Offer a very short reply. 2.48. What is the difference between the Rent(as % of GDP) in High income: nonOECD in 2010 and the Rent(as % of GDP) in Bulgaria in 2013?
Ensure brevity in your answer.  2.44. What is the difference between the Rent(as % of GDP) in High income: nonOECD in 2010 and the Rent(as % of GDP) in Congo (Democratic) in 2013?
Provide a succinct answer. 2.49. What is the difference between the Rent(as % of GDP) in Albania in 2010 and the Rent(as % of GDP) in Bulgaria in 2013?
Your response must be concise. -0.04. What is the difference between the Rent(as % of GDP) of Albania in 2010 and the Rent(as % of GDP) of Congo (Democratic) in 2013?
Your answer should be compact. 0.01. What is the difference between the Rent(as % of GDP) in Bulgaria in 2010 and the Rent(as % of GDP) in Congo (Democratic) in 2013?
Give a very brief answer. 0.01. What is the difference between the Rent(as % of GDP) in High income: nonOECD in 2011 and the Rent(as % of GDP) in Albania in 2012?
Your answer should be compact. 2.42. What is the difference between the Rent(as % of GDP) of High income: nonOECD in 2011 and the Rent(as % of GDP) of Bulgaria in 2012?
Provide a succinct answer. 2.36. What is the difference between the Rent(as % of GDP) of High income: nonOECD in 2011 and the Rent(as % of GDP) of Congo (Democratic) in 2012?
Offer a terse response. 2.43. What is the difference between the Rent(as % of GDP) in Albania in 2011 and the Rent(as % of GDP) in Bulgaria in 2012?
Provide a succinct answer. -0.06. What is the difference between the Rent(as % of GDP) in Albania in 2011 and the Rent(as % of GDP) in Congo (Democratic) in 2012?
Provide a short and direct response. 0.01. What is the difference between the Rent(as % of GDP) in Bulgaria in 2011 and the Rent(as % of GDP) in Congo (Democratic) in 2012?
Give a very brief answer. 0.1. What is the difference between the Rent(as % of GDP) of High income: nonOECD in 2011 and the Rent(as % of GDP) of Albania in 2013?
Provide a short and direct response. 2.41. What is the difference between the Rent(as % of GDP) in High income: nonOECD in 2011 and the Rent(as % of GDP) in Bulgaria in 2013?
Your answer should be very brief. 2.38. What is the difference between the Rent(as % of GDP) of High income: nonOECD in 2011 and the Rent(as % of GDP) of Congo (Democratic) in 2013?
Your response must be concise. 2.43. What is the difference between the Rent(as % of GDP) in Albania in 2011 and the Rent(as % of GDP) in Bulgaria in 2013?
Give a very brief answer. -0.04. What is the difference between the Rent(as % of GDP) of Albania in 2011 and the Rent(as % of GDP) of Congo (Democratic) in 2013?
Provide a short and direct response. 0.01. What is the difference between the Rent(as % of GDP) in Bulgaria in 2011 and the Rent(as % of GDP) in Congo (Democratic) in 2013?
Offer a terse response. 0.1. What is the difference between the Rent(as % of GDP) of High income: nonOECD in 2012 and the Rent(as % of GDP) of Albania in 2013?
Your answer should be compact. 1.81. What is the difference between the Rent(as % of GDP) of High income: nonOECD in 2012 and the Rent(as % of GDP) of Bulgaria in 2013?
Your answer should be compact. 1.77. What is the difference between the Rent(as % of GDP) of High income: nonOECD in 2012 and the Rent(as % of GDP) of Congo (Democratic) in 2013?
Your answer should be compact. 1.82. What is the difference between the Rent(as % of GDP) of Albania in 2012 and the Rent(as % of GDP) of Bulgaria in 2013?
Ensure brevity in your answer.  -0.04. What is the difference between the Rent(as % of GDP) of Albania in 2012 and the Rent(as % of GDP) of Congo (Democratic) in 2013?
Provide a succinct answer. 0.01. What is the difference between the Rent(as % of GDP) of Bulgaria in 2012 and the Rent(as % of GDP) of Congo (Democratic) in 2013?
Make the answer very short. 0.07. What is the average Rent(as % of GDP) of High income: nonOECD per year?
Offer a very short reply. 3.67. What is the average Rent(as % of GDP) of Albania per year?
Your response must be concise. 0.02. What is the average Rent(as % of GDP) in Bulgaria per year?
Your answer should be compact. 0.1. What is the average Rent(as % of GDP) of Congo (Democratic) per year?
Provide a succinct answer. 0.01. In the year 2006, what is the difference between the Rent(as % of GDP) in High income: nonOECD and Rent(as % of GDP) in Albania?
Your answer should be very brief. 5.97. In the year 2006, what is the difference between the Rent(as % of GDP) in High income: nonOECD and Rent(as % of GDP) in Bulgaria?
Offer a terse response. 5.7. In the year 2006, what is the difference between the Rent(as % of GDP) of High income: nonOECD and Rent(as % of GDP) of Congo (Democratic)?
Make the answer very short. 5.99. In the year 2006, what is the difference between the Rent(as % of GDP) of Albania and Rent(as % of GDP) of Bulgaria?
Your response must be concise. -0.27. In the year 2006, what is the difference between the Rent(as % of GDP) in Albania and Rent(as % of GDP) in Congo (Democratic)?
Your answer should be very brief. 0.02. In the year 2006, what is the difference between the Rent(as % of GDP) in Bulgaria and Rent(as % of GDP) in Congo (Democratic)?
Your answer should be very brief. 0.28. In the year 2007, what is the difference between the Rent(as % of GDP) in High income: nonOECD and Rent(as % of GDP) in Albania?
Your response must be concise. 5. In the year 2007, what is the difference between the Rent(as % of GDP) in High income: nonOECD and Rent(as % of GDP) in Bulgaria?
Keep it short and to the point. 4.9. In the year 2007, what is the difference between the Rent(as % of GDP) of High income: nonOECD and Rent(as % of GDP) of Congo (Democratic)?
Make the answer very short. 5.03. In the year 2007, what is the difference between the Rent(as % of GDP) of Albania and Rent(as % of GDP) of Bulgaria?
Offer a terse response. -0.1. In the year 2007, what is the difference between the Rent(as % of GDP) in Albania and Rent(as % of GDP) in Congo (Democratic)?
Your response must be concise. 0.02. In the year 2007, what is the difference between the Rent(as % of GDP) of Bulgaria and Rent(as % of GDP) of Congo (Democratic)?
Offer a very short reply. 0.13. In the year 2008, what is the difference between the Rent(as % of GDP) in High income: nonOECD and Rent(as % of GDP) in Albania?
Make the answer very short. 6.33. In the year 2008, what is the difference between the Rent(as % of GDP) in High income: nonOECD and Rent(as % of GDP) in Bulgaria?
Provide a succinct answer. 6.24. In the year 2008, what is the difference between the Rent(as % of GDP) in High income: nonOECD and Rent(as % of GDP) in Congo (Democratic)?
Offer a very short reply. 6.34. In the year 2008, what is the difference between the Rent(as % of GDP) of Albania and Rent(as % of GDP) of Bulgaria?
Your response must be concise. -0.09. In the year 2008, what is the difference between the Rent(as % of GDP) in Albania and Rent(as % of GDP) in Congo (Democratic)?
Provide a short and direct response. 0.01. In the year 2008, what is the difference between the Rent(as % of GDP) in Bulgaria and Rent(as % of GDP) in Congo (Democratic)?
Offer a very short reply. 0.1. In the year 2009, what is the difference between the Rent(as % of GDP) in High income: nonOECD and Rent(as % of GDP) in Albania?
Offer a terse response. 2.94. In the year 2009, what is the difference between the Rent(as % of GDP) of High income: nonOECD and Rent(as % of GDP) of Bulgaria?
Offer a very short reply. 2.94. In the year 2009, what is the difference between the Rent(as % of GDP) of High income: nonOECD and Rent(as % of GDP) of Congo (Democratic)?
Ensure brevity in your answer.  2.94. In the year 2009, what is the difference between the Rent(as % of GDP) in Albania and Rent(as % of GDP) in Bulgaria?
Keep it short and to the point. 0.01. In the year 2009, what is the difference between the Rent(as % of GDP) in Albania and Rent(as % of GDP) in Congo (Democratic)?
Offer a terse response. 0. In the year 2009, what is the difference between the Rent(as % of GDP) of Bulgaria and Rent(as % of GDP) of Congo (Democratic)?
Keep it short and to the point. -0. In the year 2010, what is the difference between the Rent(as % of GDP) of High income: nonOECD and Rent(as % of GDP) of Albania?
Keep it short and to the point. 2.48. In the year 2010, what is the difference between the Rent(as % of GDP) of High income: nonOECD and Rent(as % of GDP) of Bulgaria?
Offer a very short reply. 2.48. In the year 2010, what is the difference between the Rent(as % of GDP) in High income: nonOECD and Rent(as % of GDP) in Congo (Democratic)?
Provide a succinct answer. 2.49. In the year 2010, what is the difference between the Rent(as % of GDP) of Albania and Rent(as % of GDP) of Bulgaria?
Your answer should be very brief. -0. In the year 2010, what is the difference between the Rent(as % of GDP) of Albania and Rent(as % of GDP) of Congo (Democratic)?
Offer a very short reply. 0.01. In the year 2010, what is the difference between the Rent(as % of GDP) in Bulgaria and Rent(as % of GDP) in Congo (Democratic)?
Give a very brief answer. 0.01. In the year 2011, what is the difference between the Rent(as % of GDP) in High income: nonOECD and Rent(as % of GDP) in Albania?
Your answer should be very brief. 2.42. In the year 2011, what is the difference between the Rent(as % of GDP) in High income: nonOECD and Rent(as % of GDP) in Bulgaria?
Ensure brevity in your answer.  2.33. In the year 2011, what is the difference between the Rent(as % of GDP) of High income: nonOECD and Rent(as % of GDP) of Congo (Democratic)?
Offer a very short reply. 2.42. In the year 2011, what is the difference between the Rent(as % of GDP) of Albania and Rent(as % of GDP) of Bulgaria?
Ensure brevity in your answer.  -0.08. In the year 2011, what is the difference between the Rent(as % of GDP) in Albania and Rent(as % of GDP) in Congo (Democratic)?
Keep it short and to the point. 0.01. In the year 2011, what is the difference between the Rent(as % of GDP) of Bulgaria and Rent(as % of GDP) of Congo (Democratic)?
Your response must be concise. 0.09. In the year 2012, what is the difference between the Rent(as % of GDP) of High income: nonOECD and Rent(as % of GDP) of Albania?
Make the answer very short. 1.81. In the year 2012, what is the difference between the Rent(as % of GDP) in High income: nonOECD and Rent(as % of GDP) in Bulgaria?
Your answer should be compact. 1.75. In the year 2012, what is the difference between the Rent(as % of GDP) in High income: nonOECD and Rent(as % of GDP) in Congo (Democratic)?
Your answer should be compact. 1.82. In the year 2012, what is the difference between the Rent(as % of GDP) in Albania and Rent(as % of GDP) in Bulgaria?
Offer a terse response. -0.06. In the year 2012, what is the difference between the Rent(as % of GDP) of Albania and Rent(as % of GDP) of Congo (Democratic)?
Offer a very short reply. 0.01. In the year 2012, what is the difference between the Rent(as % of GDP) in Bulgaria and Rent(as % of GDP) in Congo (Democratic)?
Your answer should be very brief. 0.07. In the year 2013, what is the difference between the Rent(as % of GDP) in High income: nonOECD and Rent(as % of GDP) in Albania?
Offer a terse response. 2.26. In the year 2013, what is the difference between the Rent(as % of GDP) in High income: nonOECD and Rent(as % of GDP) in Bulgaria?
Your response must be concise. 2.22. In the year 2013, what is the difference between the Rent(as % of GDP) in High income: nonOECD and Rent(as % of GDP) in Congo (Democratic)?
Your response must be concise. 2.27. In the year 2013, what is the difference between the Rent(as % of GDP) of Albania and Rent(as % of GDP) of Bulgaria?
Your answer should be compact. -0.04. In the year 2013, what is the difference between the Rent(as % of GDP) in Albania and Rent(as % of GDP) in Congo (Democratic)?
Provide a short and direct response. 0.01. In the year 2013, what is the difference between the Rent(as % of GDP) in Bulgaria and Rent(as % of GDP) in Congo (Democratic)?
Your answer should be compact. 0.05. What is the ratio of the Rent(as % of GDP) in High income: nonOECD in 2006 to that in 2007?
Make the answer very short. 1.19. What is the ratio of the Rent(as % of GDP) of Albania in 2006 to that in 2007?
Offer a terse response. 0.74. What is the ratio of the Rent(as % of GDP) of Bulgaria in 2006 to that in 2007?
Ensure brevity in your answer.  2.08. What is the ratio of the Rent(as % of GDP) of Congo (Democratic) in 2006 to that in 2007?
Your answer should be compact. 0.55. What is the ratio of the Rent(as % of GDP) of High income: nonOECD in 2006 to that in 2008?
Offer a terse response. 0.94. What is the ratio of the Rent(as % of GDP) of Albania in 2006 to that in 2008?
Offer a very short reply. 1.2. What is the ratio of the Rent(as % of GDP) of Bulgaria in 2006 to that in 2008?
Provide a short and direct response. 2.58. What is the ratio of the Rent(as % of GDP) of Congo (Democratic) in 2006 to that in 2008?
Give a very brief answer. 0.44. What is the ratio of the Rent(as % of GDP) of High income: nonOECD in 2006 to that in 2009?
Your answer should be compact. 2.04. What is the ratio of the Rent(as % of GDP) in Albania in 2006 to that in 2009?
Your answer should be compact. 2.63. What is the ratio of the Rent(as % of GDP) of Bulgaria in 2006 to that in 2009?
Make the answer very short. 69.34. What is the ratio of the Rent(as % of GDP) in Congo (Democratic) in 2006 to that in 2009?
Offer a very short reply. 0.91. What is the ratio of the Rent(as % of GDP) in High income: nonOECD in 2006 to that in 2010?
Your answer should be compact. 2.41. What is the ratio of the Rent(as % of GDP) of Albania in 2006 to that in 2010?
Make the answer very short. 1.83. What is the ratio of the Rent(as % of GDP) in Bulgaria in 2006 to that in 2010?
Provide a short and direct response. 16.42. What is the ratio of the Rent(as % of GDP) of Congo (Democratic) in 2006 to that in 2010?
Ensure brevity in your answer.  1.09. What is the ratio of the Rent(as % of GDP) in High income: nonOECD in 2006 to that in 2011?
Your answer should be compact. 2.47. What is the ratio of the Rent(as % of GDP) in Albania in 2006 to that in 2011?
Offer a very short reply. 1.75. What is the ratio of the Rent(as % of GDP) in Bulgaria in 2006 to that in 2011?
Make the answer very short. 2.92. What is the ratio of the Rent(as % of GDP) in Congo (Democratic) in 2006 to that in 2011?
Offer a very short reply. 1.14. What is the ratio of the Rent(as % of GDP) in High income: nonOECD in 2006 to that in 2012?
Offer a terse response. 3.29. What is the ratio of the Rent(as % of GDP) of Albania in 2006 to that in 2012?
Offer a very short reply. 1.93. What is the ratio of the Rent(as % of GDP) in Bulgaria in 2006 to that in 2012?
Offer a terse response. 3.97. What is the ratio of the Rent(as % of GDP) in Congo (Democratic) in 2006 to that in 2012?
Provide a short and direct response. 1.53. What is the ratio of the Rent(as % of GDP) in High income: nonOECD in 2006 to that in 2013?
Your answer should be very brief. 2.64. What is the ratio of the Rent(as % of GDP) in Albania in 2006 to that in 2013?
Keep it short and to the point. 1.72. What is the ratio of the Rent(as % of GDP) of Bulgaria in 2006 to that in 2013?
Provide a succinct answer. 5.45. What is the ratio of the Rent(as % of GDP) of Congo (Democratic) in 2006 to that in 2013?
Keep it short and to the point. 1.52. What is the ratio of the Rent(as % of GDP) of High income: nonOECD in 2007 to that in 2008?
Your answer should be compact. 0.79. What is the ratio of the Rent(as % of GDP) of Albania in 2007 to that in 2008?
Give a very brief answer. 1.62. What is the ratio of the Rent(as % of GDP) in Bulgaria in 2007 to that in 2008?
Offer a terse response. 1.24. What is the ratio of the Rent(as % of GDP) in Congo (Democratic) in 2007 to that in 2008?
Provide a short and direct response. 0.8. What is the ratio of the Rent(as % of GDP) of High income: nonOECD in 2007 to that in 2009?
Your answer should be compact. 1.71. What is the ratio of the Rent(as % of GDP) of Albania in 2007 to that in 2009?
Offer a very short reply. 3.55. What is the ratio of the Rent(as % of GDP) in Bulgaria in 2007 to that in 2009?
Give a very brief answer. 33.32. What is the ratio of the Rent(as % of GDP) of Congo (Democratic) in 2007 to that in 2009?
Provide a succinct answer. 1.65. What is the ratio of the Rent(as % of GDP) in High income: nonOECD in 2007 to that in 2010?
Your response must be concise. 2.02. What is the ratio of the Rent(as % of GDP) in Albania in 2007 to that in 2010?
Your answer should be very brief. 2.46. What is the ratio of the Rent(as % of GDP) in Bulgaria in 2007 to that in 2010?
Offer a very short reply. 7.89. What is the ratio of the Rent(as % of GDP) of Congo (Democratic) in 2007 to that in 2010?
Ensure brevity in your answer.  1.97. What is the ratio of the Rent(as % of GDP) of High income: nonOECD in 2007 to that in 2011?
Keep it short and to the point. 2.07. What is the ratio of the Rent(as % of GDP) of Albania in 2007 to that in 2011?
Keep it short and to the point. 2.36. What is the ratio of the Rent(as % of GDP) in Bulgaria in 2007 to that in 2011?
Your answer should be very brief. 1.4. What is the ratio of the Rent(as % of GDP) of Congo (Democratic) in 2007 to that in 2011?
Offer a terse response. 2.06. What is the ratio of the Rent(as % of GDP) in High income: nonOECD in 2007 to that in 2012?
Your answer should be compact. 2.76. What is the ratio of the Rent(as % of GDP) of Albania in 2007 to that in 2012?
Provide a short and direct response. 2.6. What is the ratio of the Rent(as % of GDP) in Bulgaria in 2007 to that in 2012?
Offer a very short reply. 1.91. What is the ratio of the Rent(as % of GDP) of Congo (Democratic) in 2007 to that in 2012?
Ensure brevity in your answer.  2.75. What is the ratio of the Rent(as % of GDP) in High income: nonOECD in 2007 to that in 2013?
Keep it short and to the point. 2.22. What is the ratio of the Rent(as % of GDP) in Albania in 2007 to that in 2013?
Offer a terse response. 2.31. What is the ratio of the Rent(as % of GDP) of Bulgaria in 2007 to that in 2013?
Give a very brief answer. 2.62. What is the ratio of the Rent(as % of GDP) in Congo (Democratic) in 2007 to that in 2013?
Your response must be concise. 2.74. What is the ratio of the Rent(as % of GDP) of High income: nonOECD in 2008 to that in 2009?
Offer a terse response. 2.16. What is the ratio of the Rent(as % of GDP) in Albania in 2008 to that in 2009?
Your answer should be very brief. 2.19. What is the ratio of the Rent(as % of GDP) in Bulgaria in 2008 to that in 2009?
Provide a succinct answer. 26.83. What is the ratio of the Rent(as % of GDP) of Congo (Democratic) in 2008 to that in 2009?
Offer a very short reply. 2.06. What is the ratio of the Rent(as % of GDP) of High income: nonOECD in 2008 to that in 2010?
Offer a very short reply. 2.55. What is the ratio of the Rent(as % of GDP) in Albania in 2008 to that in 2010?
Your response must be concise. 1.52. What is the ratio of the Rent(as % of GDP) of Bulgaria in 2008 to that in 2010?
Provide a short and direct response. 6.36. What is the ratio of the Rent(as % of GDP) in Congo (Democratic) in 2008 to that in 2010?
Provide a succinct answer. 2.46. What is the ratio of the Rent(as % of GDP) in High income: nonOECD in 2008 to that in 2011?
Make the answer very short. 2.61. What is the ratio of the Rent(as % of GDP) in Albania in 2008 to that in 2011?
Your answer should be compact. 1.45. What is the ratio of the Rent(as % of GDP) in Bulgaria in 2008 to that in 2011?
Offer a very short reply. 1.13. What is the ratio of the Rent(as % of GDP) of Congo (Democratic) in 2008 to that in 2011?
Offer a very short reply. 2.58. What is the ratio of the Rent(as % of GDP) in High income: nonOECD in 2008 to that in 2012?
Provide a succinct answer. 3.48. What is the ratio of the Rent(as % of GDP) of Albania in 2008 to that in 2012?
Your answer should be compact. 1.6. What is the ratio of the Rent(as % of GDP) in Bulgaria in 2008 to that in 2012?
Provide a succinct answer. 1.54. What is the ratio of the Rent(as % of GDP) of Congo (Democratic) in 2008 to that in 2012?
Ensure brevity in your answer.  3.44. What is the ratio of the Rent(as % of GDP) of High income: nonOECD in 2008 to that in 2013?
Give a very brief answer. 2.79. What is the ratio of the Rent(as % of GDP) in Albania in 2008 to that in 2013?
Make the answer very short. 1.43. What is the ratio of the Rent(as % of GDP) in Bulgaria in 2008 to that in 2013?
Your response must be concise. 2.11. What is the ratio of the Rent(as % of GDP) in Congo (Democratic) in 2008 to that in 2013?
Provide a succinct answer. 3.43. What is the ratio of the Rent(as % of GDP) in High income: nonOECD in 2009 to that in 2010?
Provide a succinct answer. 1.18. What is the ratio of the Rent(as % of GDP) in Albania in 2009 to that in 2010?
Provide a succinct answer. 0.69. What is the ratio of the Rent(as % of GDP) of Bulgaria in 2009 to that in 2010?
Your answer should be very brief. 0.24. What is the ratio of the Rent(as % of GDP) in Congo (Democratic) in 2009 to that in 2010?
Your answer should be very brief. 1.2. What is the ratio of the Rent(as % of GDP) in High income: nonOECD in 2009 to that in 2011?
Your answer should be very brief. 1.21. What is the ratio of the Rent(as % of GDP) of Albania in 2009 to that in 2011?
Keep it short and to the point. 0.67. What is the ratio of the Rent(as % of GDP) in Bulgaria in 2009 to that in 2011?
Ensure brevity in your answer.  0.04. What is the ratio of the Rent(as % of GDP) of Congo (Democratic) in 2009 to that in 2011?
Offer a terse response. 1.25. What is the ratio of the Rent(as % of GDP) of High income: nonOECD in 2009 to that in 2012?
Offer a very short reply. 1.61. What is the ratio of the Rent(as % of GDP) of Albania in 2009 to that in 2012?
Offer a terse response. 0.73. What is the ratio of the Rent(as % of GDP) in Bulgaria in 2009 to that in 2012?
Provide a short and direct response. 0.06. What is the ratio of the Rent(as % of GDP) in Congo (Democratic) in 2009 to that in 2012?
Make the answer very short. 1.67. What is the ratio of the Rent(as % of GDP) of High income: nonOECD in 2009 to that in 2013?
Your response must be concise. 1.3. What is the ratio of the Rent(as % of GDP) in Albania in 2009 to that in 2013?
Keep it short and to the point. 0.65. What is the ratio of the Rent(as % of GDP) of Bulgaria in 2009 to that in 2013?
Provide a succinct answer. 0.08. What is the ratio of the Rent(as % of GDP) in Congo (Democratic) in 2009 to that in 2013?
Ensure brevity in your answer.  1.66. What is the ratio of the Rent(as % of GDP) in High income: nonOECD in 2010 to that in 2011?
Offer a terse response. 1.03. What is the ratio of the Rent(as % of GDP) in Albania in 2010 to that in 2011?
Provide a short and direct response. 0.96. What is the ratio of the Rent(as % of GDP) in Bulgaria in 2010 to that in 2011?
Your answer should be compact. 0.18. What is the ratio of the Rent(as % of GDP) in Congo (Democratic) in 2010 to that in 2011?
Ensure brevity in your answer.  1.05. What is the ratio of the Rent(as % of GDP) in High income: nonOECD in 2010 to that in 2012?
Ensure brevity in your answer.  1.37. What is the ratio of the Rent(as % of GDP) in Albania in 2010 to that in 2012?
Offer a terse response. 1.06. What is the ratio of the Rent(as % of GDP) in Bulgaria in 2010 to that in 2012?
Keep it short and to the point. 0.24. What is the ratio of the Rent(as % of GDP) of Congo (Democratic) in 2010 to that in 2012?
Give a very brief answer. 1.4. What is the ratio of the Rent(as % of GDP) in High income: nonOECD in 2010 to that in 2013?
Give a very brief answer. 1.1. What is the ratio of the Rent(as % of GDP) of Albania in 2010 to that in 2013?
Offer a very short reply. 0.94. What is the ratio of the Rent(as % of GDP) of Bulgaria in 2010 to that in 2013?
Ensure brevity in your answer.  0.33. What is the ratio of the Rent(as % of GDP) of Congo (Democratic) in 2010 to that in 2013?
Make the answer very short. 1.39. What is the ratio of the Rent(as % of GDP) of High income: nonOECD in 2011 to that in 2012?
Your answer should be compact. 1.33. What is the ratio of the Rent(as % of GDP) in Albania in 2011 to that in 2012?
Offer a terse response. 1.1. What is the ratio of the Rent(as % of GDP) in Bulgaria in 2011 to that in 2012?
Offer a terse response. 1.36. What is the ratio of the Rent(as % of GDP) in Congo (Democratic) in 2011 to that in 2012?
Keep it short and to the point. 1.33. What is the ratio of the Rent(as % of GDP) of High income: nonOECD in 2011 to that in 2013?
Offer a terse response. 1.07. What is the ratio of the Rent(as % of GDP) of Albania in 2011 to that in 2013?
Offer a very short reply. 0.98. What is the ratio of the Rent(as % of GDP) of Bulgaria in 2011 to that in 2013?
Make the answer very short. 1.86. What is the ratio of the Rent(as % of GDP) of Congo (Democratic) in 2011 to that in 2013?
Provide a succinct answer. 1.33. What is the ratio of the Rent(as % of GDP) of High income: nonOECD in 2012 to that in 2013?
Your answer should be very brief. 0.8. What is the ratio of the Rent(as % of GDP) in Albania in 2012 to that in 2013?
Offer a very short reply. 0.89. What is the ratio of the Rent(as % of GDP) in Bulgaria in 2012 to that in 2013?
Provide a short and direct response. 1.37. What is the ratio of the Rent(as % of GDP) in Congo (Democratic) in 2012 to that in 2013?
Provide a succinct answer. 1. What is the difference between the highest and the second highest Rent(as % of GDP) in High income: nonOECD?
Your answer should be very brief. 0.36. What is the difference between the highest and the second highest Rent(as % of GDP) in Albania?
Ensure brevity in your answer.  0.01. What is the difference between the highest and the second highest Rent(as % of GDP) in Bulgaria?
Provide a succinct answer. 0.15. What is the difference between the highest and the second highest Rent(as % of GDP) of Congo (Democratic)?
Your response must be concise. 0. What is the difference between the highest and the lowest Rent(as % of GDP) of High income: nonOECD?
Your answer should be compact. 4.53. What is the difference between the highest and the lowest Rent(as % of GDP) in Albania?
Make the answer very short. 0.03. What is the difference between the highest and the lowest Rent(as % of GDP) of Bulgaria?
Give a very brief answer. 0.29. What is the difference between the highest and the lowest Rent(as % of GDP) in Congo (Democratic)?
Ensure brevity in your answer.  0.01. 